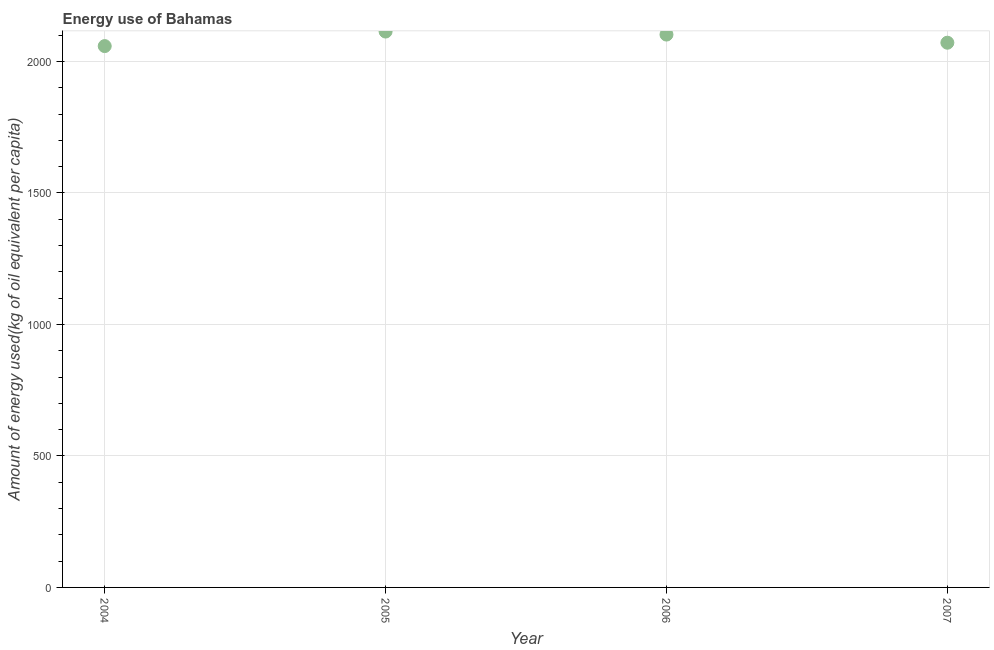What is the amount of energy used in 2007?
Give a very brief answer. 2071.53. Across all years, what is the maximum amount of energy used?
Ensure brevity in your answer.  2113.94. Across all years, what is the minimum amount of energy used?
Keep it short and to the point. 2058.67. What is the sum of the amount of energy used?
Provide a succinct answer. 8346.57. What is the difference between the amount of energy used in 2004 and 2007?
Offer a very short reply. -12.86. What is the average amount of energy used per year?
Ensure brevity in your answer.  2086.64. What is the median amount of energy used?
Ensure brevity in your answer.  2086.98. What is the ratio of the amount of energy used in 2006 to that in 2007?
Provide a short and direct response. 1.01. Is the amount of energy used in 2006 less than that in 2007?
Provide a short and direct response. No. Is the difference between the amount of energy used in 2004 and 2006 greater than the difference between any two years?
Provide a succinct answer. No. What is the difference between the highest and the second highest amount of energy used?
Your answer should be compact. 11.5. What is the difference between the highest and the lowest amount of energy used?
Make the answer very short. 55.27. In how many years, is the amount of energy used greater than the average amount of energy used taken over all years?
Give a very brief answer. 2. Does the graph contain any zero values?
Your answer should be compact. No. What is the title of the graph?
Your answer should be compact. Energy use of Bahamas. What is the label or title of the X-axis?
Give a very brief answer. Year. What is the label or title of the Y-axis?
Make the answer very short. Amount of energy used(kg of oil equivalent per capita). What is the Amount of energy used(kg of oil equivalent per capita) in 2004?
Provide a succinct answer. 2058.67. What is the Amount of energy used(kg of oil equivalent per capita) in 2005?
Your answer should be compact. 2113.94. What is the Amount of energy used(kg of oil equivalent per capita) in 2006?
Your response must be concise. 2102.44. What is the Amount of energy used(kg of oil equivalent per capita) in 2007?
Your response must be concise. 2071.53. What is the difference between the Amount of energy used(kg of oil equivalent per capita) in 2004 and 2005?
Your answer should be compact. -55.27. What is the difference between the Amount of energy used(kg of oil equivalent per capita) in 2004 and 2006?
Make the answer very short. -43.77. What is the difference between the Amount of energy used(kg of oil equivalent per capita) in 2004 and 2007?
Keep it short and to the point. -12.86. What is the difference between the Amount of energy used(kg of oil equivalent per capita) in 2005 and 2006?
Provide a succinct answer. 11.5. What is the difference between the Amount of energy used(kg of oil equivalent per capita) in 2005 and 2007?
Provide a short and direct response. 42.41. What is the difference between the Amount of energy used(kg of oil equivalent per capita) in 2006 and 2007?
Ensure brevity in your answer.  30.91. What is the ratio of the Amount of energy used(kg of oil equivalent per capita) in 2004 to that in 2005?
Your answer should be very brief. 0.97. What is the ratio of the Amount of energy used(kg of oil equivalent per capita) in 2005 to that in 2006?
Keep it short and to the point. 1. 